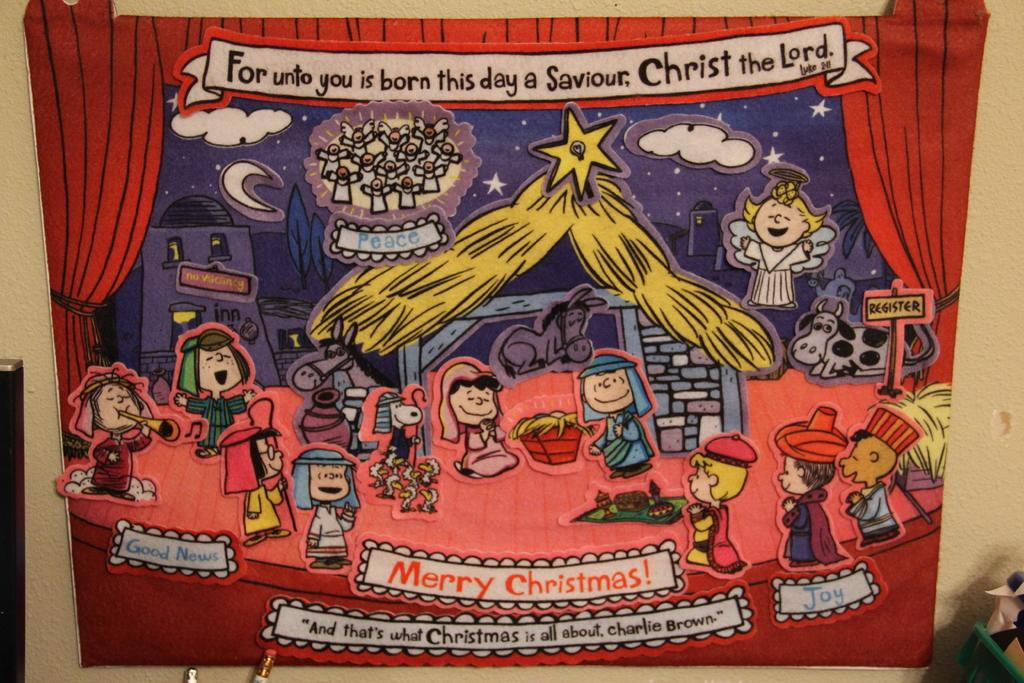Provide a one-sentence caption for the provided image. A cartoon drawing that is about Christmas and mentions the character Charlie Brown. 